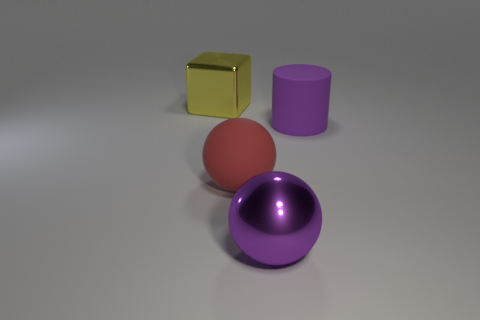Add 2 yellow shiny things. How many objects exist? 6 Subtract all cubes. How many objects are left? 3 Subtract all purple spheres. How many spheres are left? 1 Add 1 tiny yellow rubber objects. How many tiny yellow rubber objects exist? 1 Subtract 1 red spheres. How many objects are left? 3 Subtract all yellow cylinders. Subtract all green balls. How many cylinders are left? 1 Subtract all big rubber cylinders. Subtract all purple rubber cylinders. How many objects are left? 2 Add 2 metallic spheres. How many metallic spheres are left? 3 